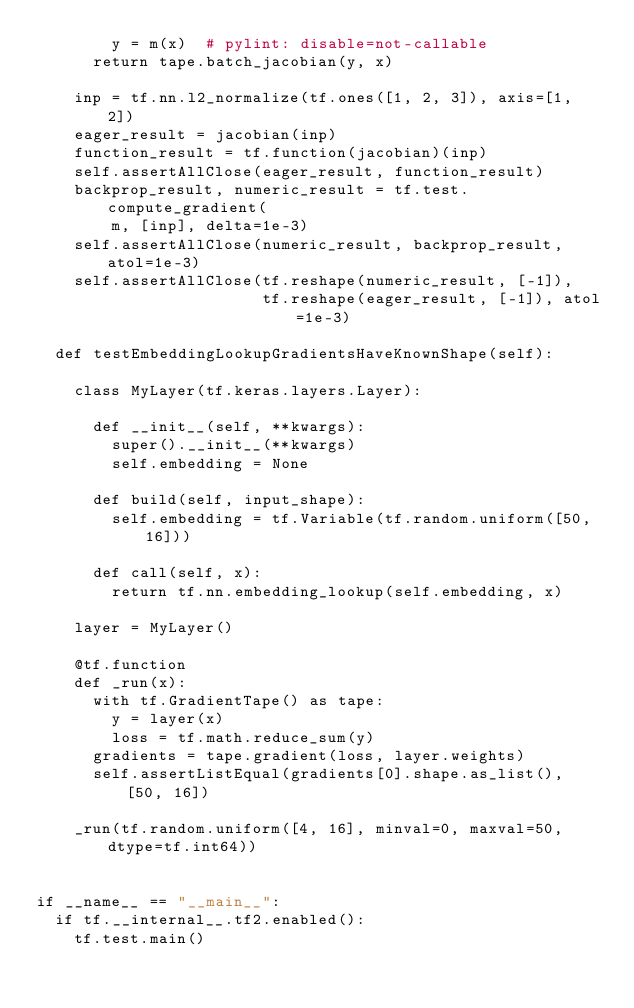Convert code to text. <code><loc_0><loc_0><loc_500><loc_500><_Python_>        y = m(x)  # pylint: disable=not-callable
      return tape.batch_jacobian(y, x)

    inp = tf.nn.l2_normalize(tf.ones([1, 2, 3]), axis=[1, 2])
    eager_result = jacobian(inp)
    function_result = tf.function(jacobian)(inp)
    self.assertAllClose(eager_result, function_result)
    backprop_result, numeric_result = tf.test.compute_gradient(
        m, [inp], delta=1e-3)
    self.assertAllClose(numeric_result, backprop_result, atol=1e-3)
    self.assertAllClose(tf.reshape(numeric_result, [-1]),
                        tf.reshape(eager_result, [-1]), atol=1e-3)

  def testEmbeddingLookupGradientsHaveKnownShape(self):

    class MyLayer(tf.keras.layers.Layer):

      def __init__(self, **kwargs):
        super().__init__(**kwargs)
        self.embedding = None

      def build(self, input_shape):
        self.embedding = tf.Variable(tf.random.uniform([50, 16]))

      def call(self, x):
        return tf.nn.embedding_lookup(self.embedding, x)

    layer = MyLayer()

    @tf.function
    def _run(x):
      with tf.GradientTape() as tape:
        y = layer(x)
        loss = tf.math.reduce_sum(y)
      gradients = tape.gradient(loss, layer.weights)
      self.assertListEqual(gradients[0].shape.as_list(), [50, 16])

    _run(tf.random.uniform([4, 16], minval=0, maxval=50, dtype=tf.int64))


if __name__ == "__main__":
  if tf.__internal__.tf2.enabled():
    tf.test.main()
</code> 